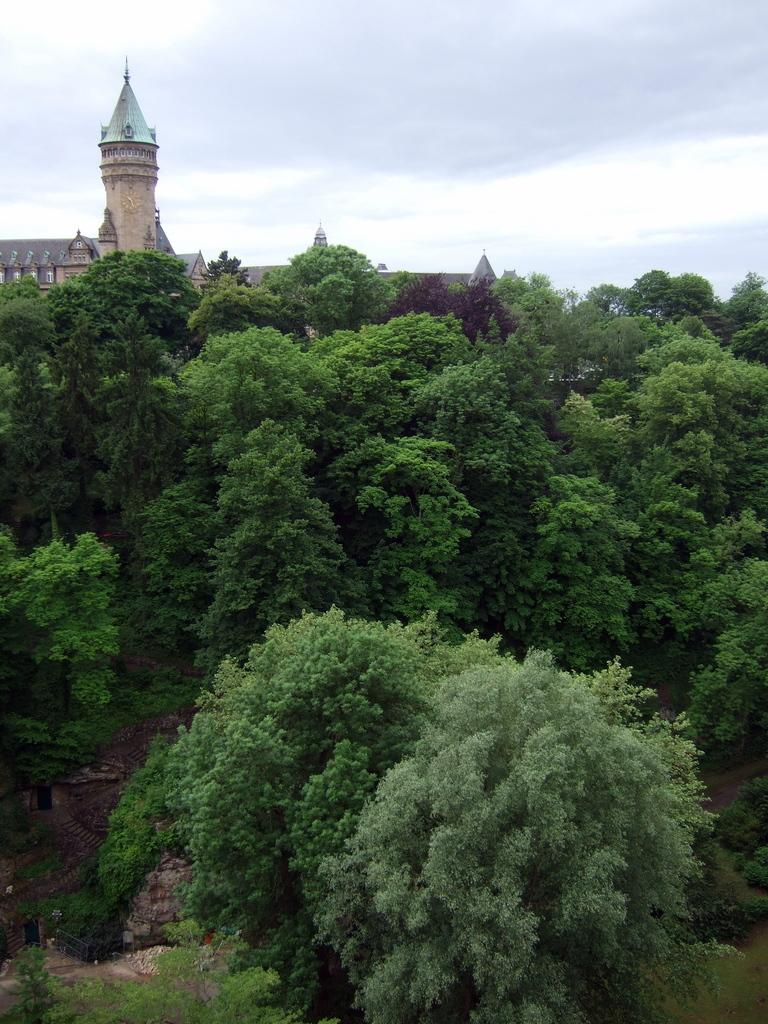What type of vegetation is in the foreground of the image? There are trees in the foreground of the image. What structure is located in the middle of the image? There is a building in the middle of the image. What is visible at the top of the image? The sky is visible at the top of the image. Who is the owner of the drum in the image? There is no drum present in the image. What is the best way to reach the building in the image? The image does not provide information about the location or accessibility of the building, so it is not possible to determine the best way to reach it. 